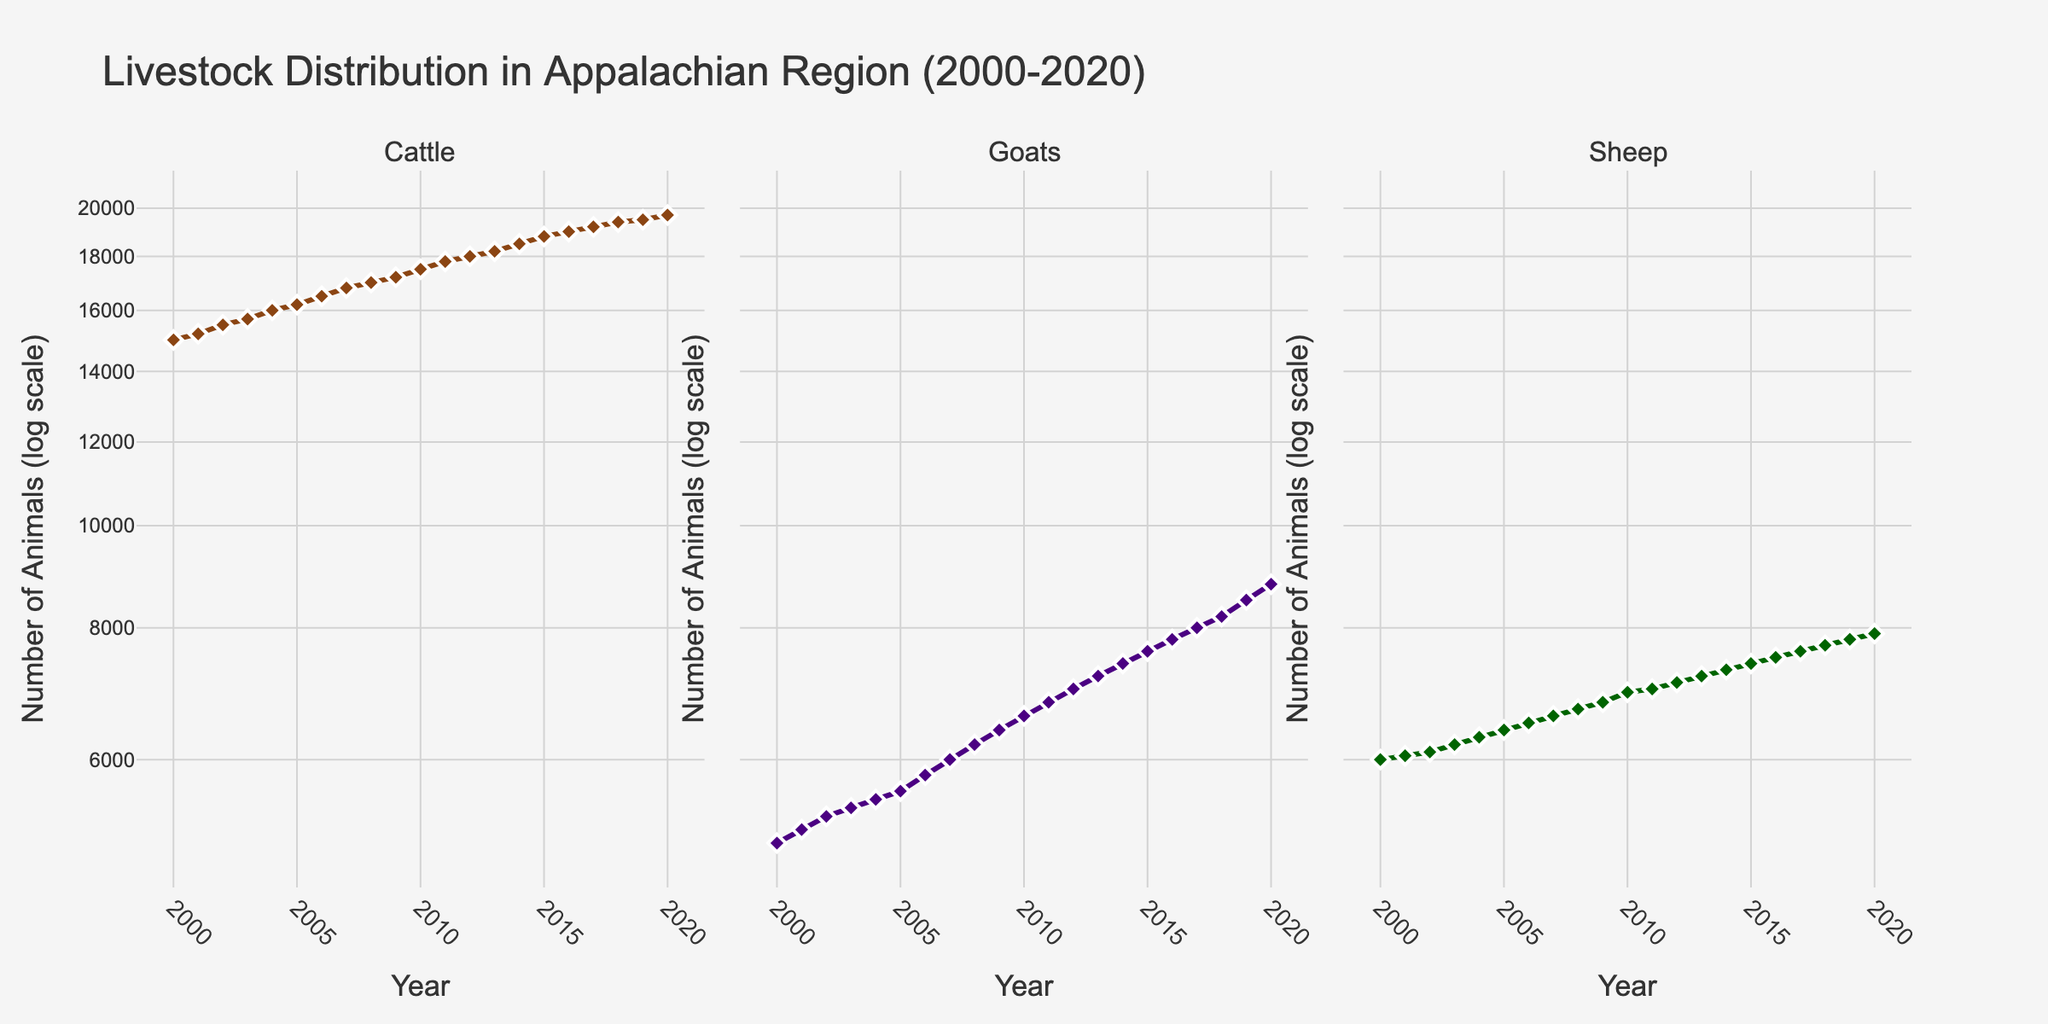How many types of livestock are plotted in the figure? The figure has three subplots, each labeled with a type of livestock: Cattle, Goats, and Sheep. This indicates that there are three types of livestock plotted in the figure.
Answer: 3 What is the title of the figure? The title is displayed at the top of the figure and reads "Livestock Distribution in Appalachian Region (2000-2020)."
Answer: Livestock Distribution in Appalachian Region (2000-2020) How many data points are shown for each type of livestock? The x-axis represents the years from 2000 to 2020, inclusive. This results in a total of 21 data points for each livestock type.
Answer: 21 What color are the lines representing Cattle, Goats, and Sheep? The color used for Cattle is brown, for Goats is indigo, and for Sheep is dark green. These colors differentiate the livestock types in the subplots.
Answer: Cattle: brown, Goats: indigo, Sheep: dark green Between which years did the number of Cattle exceed 19,000? Looking at the Cattle subplot with its log-scaled y-axis, the line crosses the 19,000 mark between the years 2016 and 2020.
Answer: 2016-2020 Which type of livestock shows the highest increase in numbers from 2000 to 2020? By comparing the initial and final values in each subplot, Goats increased from 5,000 to 8,800, which is the largest increase in numbers compared to Cattle and Sheep.
Answer: Goats What is the approximate rate of increase in the number of Goats from 2000 to 2020? The Goats' number increased from 5,000 in 2000 to 8,800 in 2020. This is an increase of 3,800 over 20 years, or approximately 190 goats per year.
Answer: 190 goats per year In which year did the number of Sheep first reach 7,000? Referring to the Sheep subplot, the log-scaled y-axis shows that the number of Sheep reached 7,000 in the year 2011.
Answer: 2011 Is the increase in livestock numbers generally consistent or fluctuating over the years? By observing the trend lines in each subplot, one can see that the increase is generally consistent for all livestock types, with steady growth over the years.
Answer: Consistent Which livestock type had the smallest increase in numbers from 2000 to 2020? By comparing the initial and final values, Sheep increased from 6,000 to 7,900, which is the smallest increase among the three types of livestock.
Answer: Sheep 